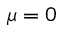<formula> <loc_0><loc_0><loc_500><loc_500>\mu = 0</formula> 